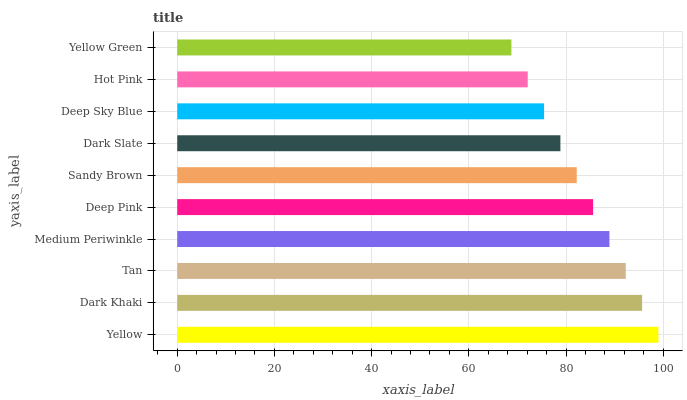Is Yellow Green the minimum?
Answer yes or no. Yes. Is Yellow the maximum?
Answer yes or no. Yes. Is Dark Khaki the minimum?
Answer yes or no. No. Is Dark Khaki the maximum?
Answer yes or no. No. Is Yellow greater than Dark Khaki?
Answer yes or no. Yes. Is Dark Khaki less than Yellow?
Answer yes or no. Yes. Is Dark Khaki greater than Yellow?
Answer yes or no. No. Is Yellow less than Dark Khaki?
Answer yes or no. No. Is Deep Pink the high median?
Answer yes or no. Yes. Is Sandy Brown the low median?
Answer yes or no. Yes. Is Yellow the high median?
Answer yes or no. No. Is Medium Periwinkle the low median?
Answer yes or no. No. 